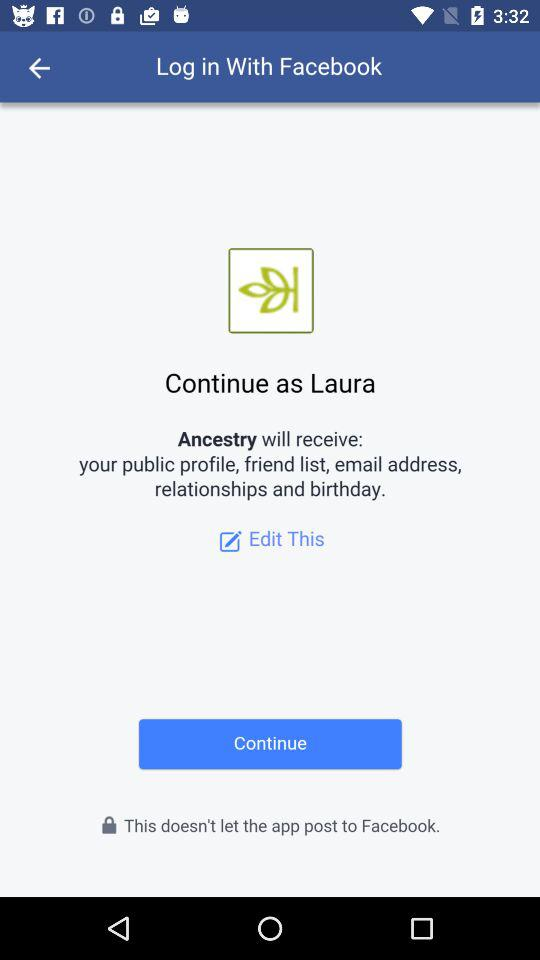What is the name of the user? The name of the user is Laura. 